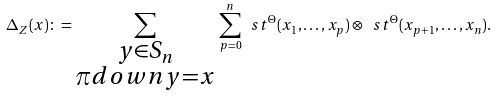Convert formula to latex. <formula><loc_0><loc_0><loc_500><loc_500>\Delta _ { Z } ( x ) \colon = \sum _ { \substack { y \in S _ { n } \\ \pi d o w n y = x } } \, \sum _ { p = 0 } ^ { n } \ s t ^ { \Theta } ( x _ { 1 } , \dots , x _ { p } ) \otimes \ s t ^ { \Theta } ( x _ { p + 1 } , \dots , x _ { n } ) .</formula> 